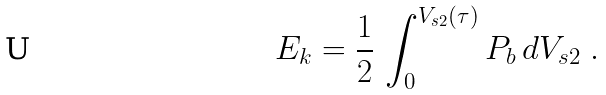Convert formula to latex. <formula><loc_0><loc_0><loc_500><loc_500>E _ { k } = \frac { 1 } { 2 } \, \int _ { 0 } ^ { V _ { s 2 } ( \tau ) } P _ { b } \, d V _ { s 2 } \ .</formula> 